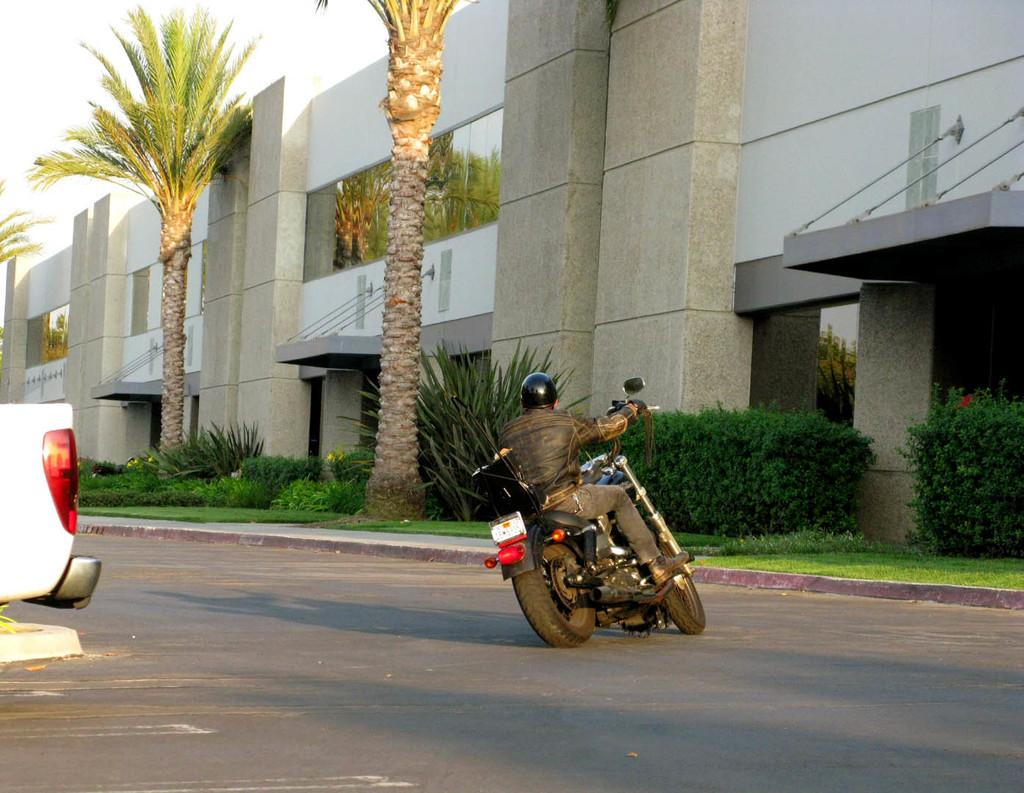What is the man in the image doing? The man is riding a motorbike on the road. What can be seen in the image besides the man and the motorbike? There are plants and trees in the image. What is visible in the background of the image? There is a building and the sky visible in the background of the image. What type of quince is being used as a decoration on the building in the image? There is no quince present in the image, as it is a fruit and not mentioned in the facts provided. 